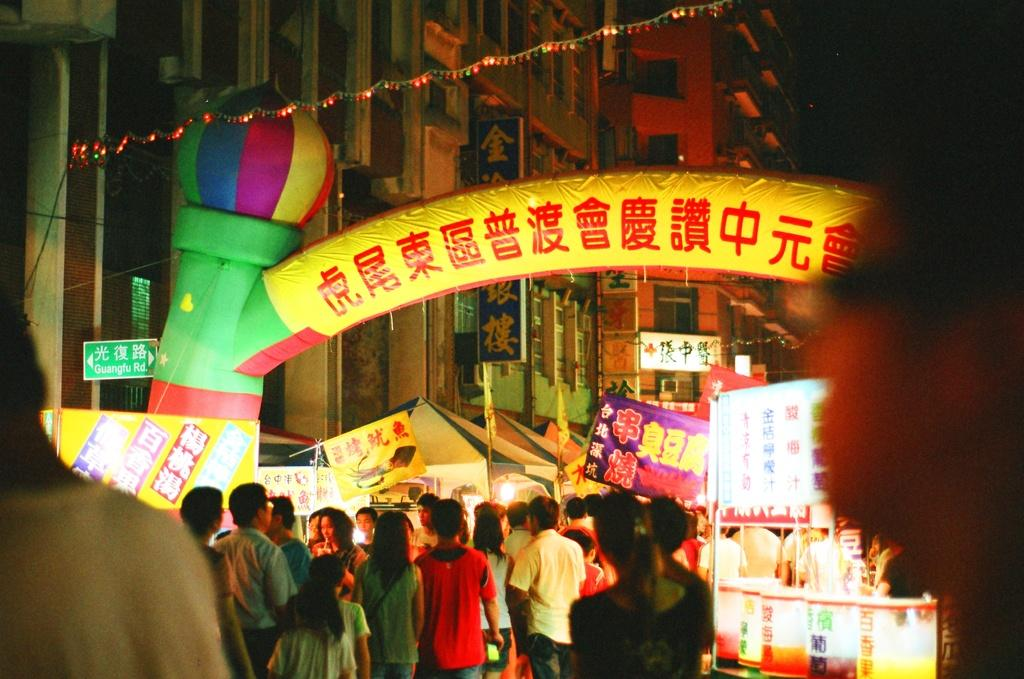Who or what is present in the image? There are people in the image. What objects can be seen in the image? There are boards, an arch, and lights visible in the image. What type of structures are in the image? There are buildings in the image. How would you describe the lighting in the image? The lights in the image provide illumination. What is the overall appearance of the background in the image? The background of the image is dark. What type of neck can be seen on the library in the image? There is no library present in the image, and therefore no neck can be observed. How many sticks are visible in the image? There are no sticks visible in the image. 